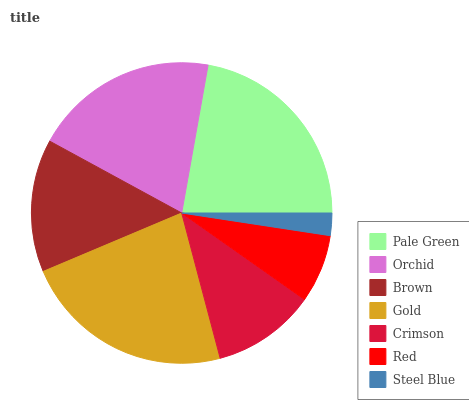Is Steel Blue the minimum?
Answer yes or no. Yes. Is Gold the maximum?
Answer yes or no. Yes. Is Orchid the minimum?
Answer yes or no. No. Is Orchid the maximum?
Answer yes or no. No. Is Pale Green greater than Orchid?
Answer yes or no. Yes. Is Orchid less than Pale Green?
Answer yes or no. Yes. Is Orchid greater than Pale Green?
Answer yes or no. No. Is Pale Green less than Orchid?
Answer yes or no. No. Is Brown the high median?
Answer yes or no. Yes. Is Brown the low median?
Answer yes or no. Yes. Is Pale Green the high median?
Answer yes or no. No. Is Orchid the low median?
Answer yes or no. No. 